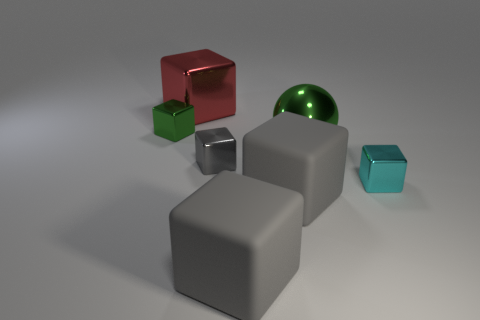What size is the cyan thing that is in front of the green thing that is left of the red metallic cube?
Make the answer very short. Small. What is the shape of the large green metallic thing?
Provide a short and direct response. Sphere. What is the material of the big object behind the green cube?
Provide a succinct answer. Metal. What is the color of the metal block on the left side of the large thing behind the small block that is to the left of the large red metal thing?
Provide a succinct answer. Green. There is a metal object that is the same size as the green shiny sphere; what color is it?
Provide a succinct answer. Red. What number of metallic things are gray cubes or small objects?
Provide a succinct answer. 3. There is a big block that is the same material as the large sphere; what is its color?
Offer a very short reply. Red. How many objects are either small metal things that are to the left of the large green shiny thing or cubes that are on the right side of the large green metallic object?
Your answer should be very brief. 3. How big is the green metal object that is on the right side of the small shiny object that is behind the green metal object that is in front of the green block?
Offer a terse response. Large. Is the number of tiny cyan objects that are behind the red thing the same as the number of purple rubber objects?
Your response must be concise. Yes. 